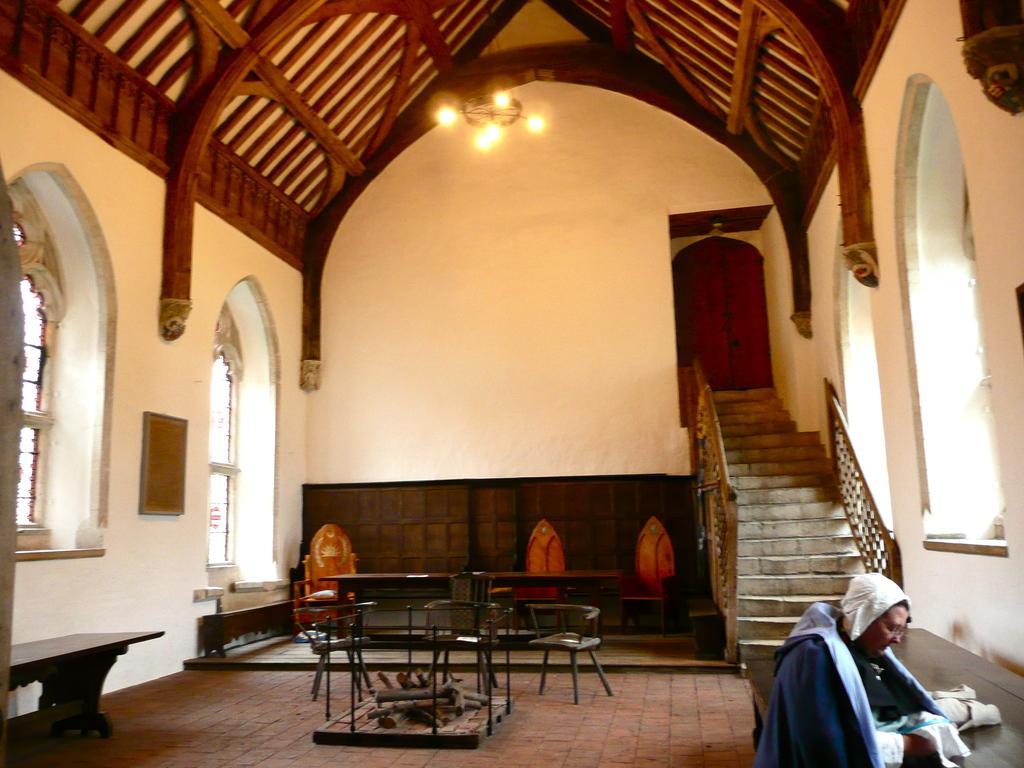Could you give a brief overview of what you see in this image? here in this picture we can see the living room here we can see the table, chair,we can also see the person sitting here,we can also see the staircase near to the wall,we can see the lamp. 